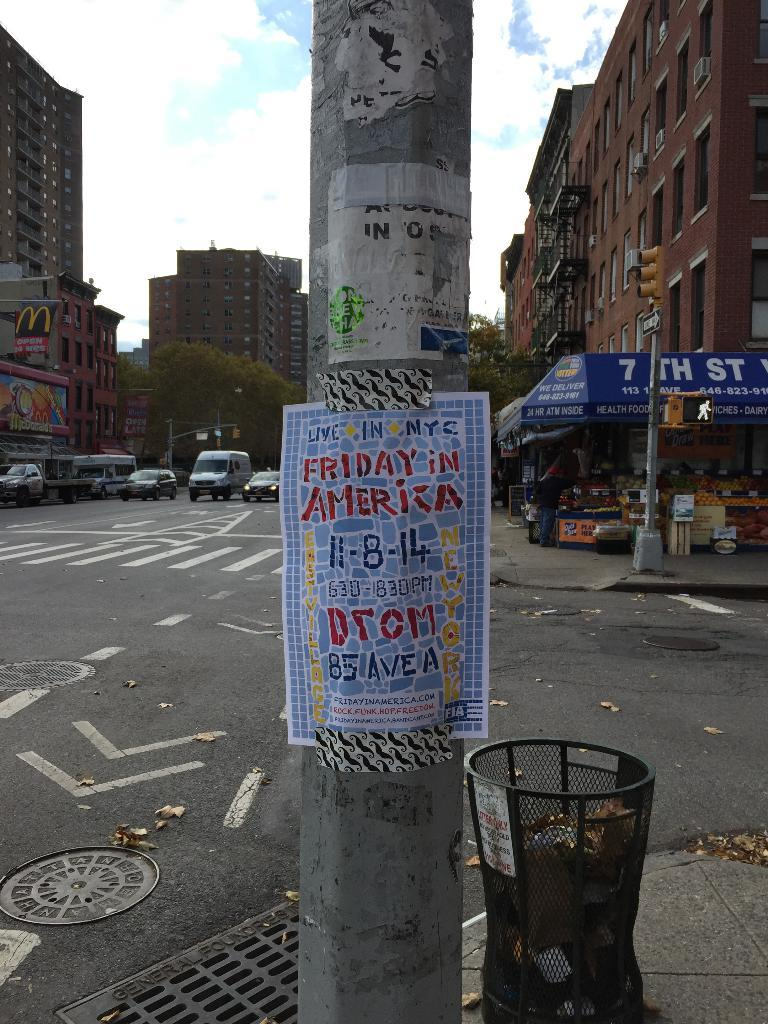<image>
Relay a brief, clear account of the picture shown. A flyer says "LIVE IN NYC" on a pole. 